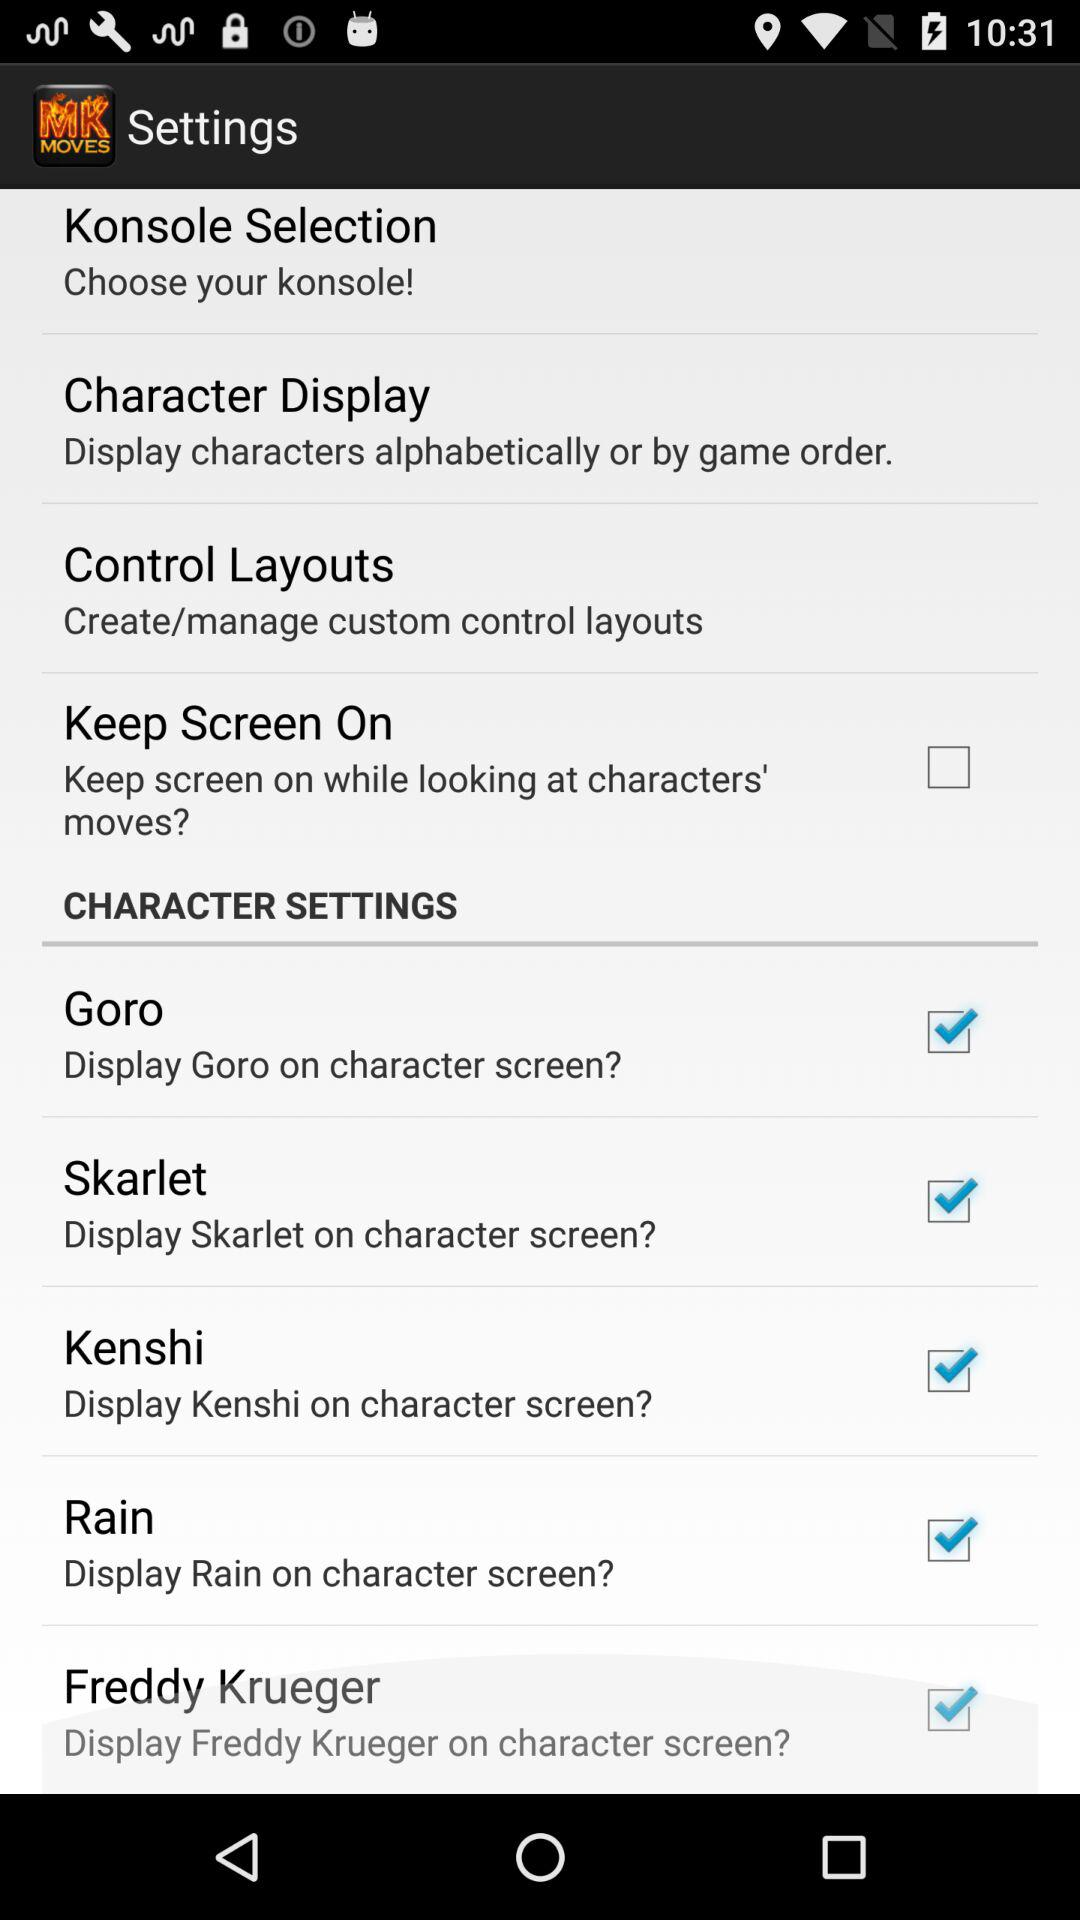What is the status of "Goro"? The status is "on". 